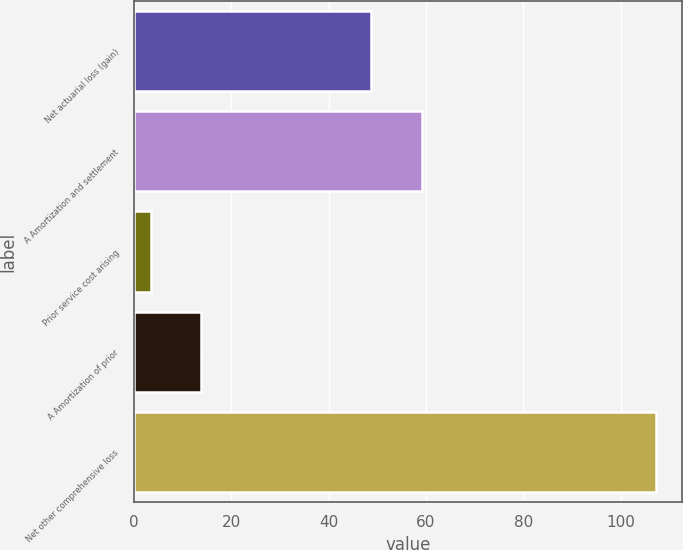Convert chart. <chart><loc_0><loc_0><loc_500><loc_500><bar_chart><fcel>Net actuarial loss (gain)<fcel>A Amortization and settlement<fcel>Prior service cost arising<fcel>A Amortization of prior<fcel>Net other comprehensive loss<nl><fcel>48.8<fcel>59.18<fcel>3.4<fcel>13.78<fcel>107.2<nl></chart> 